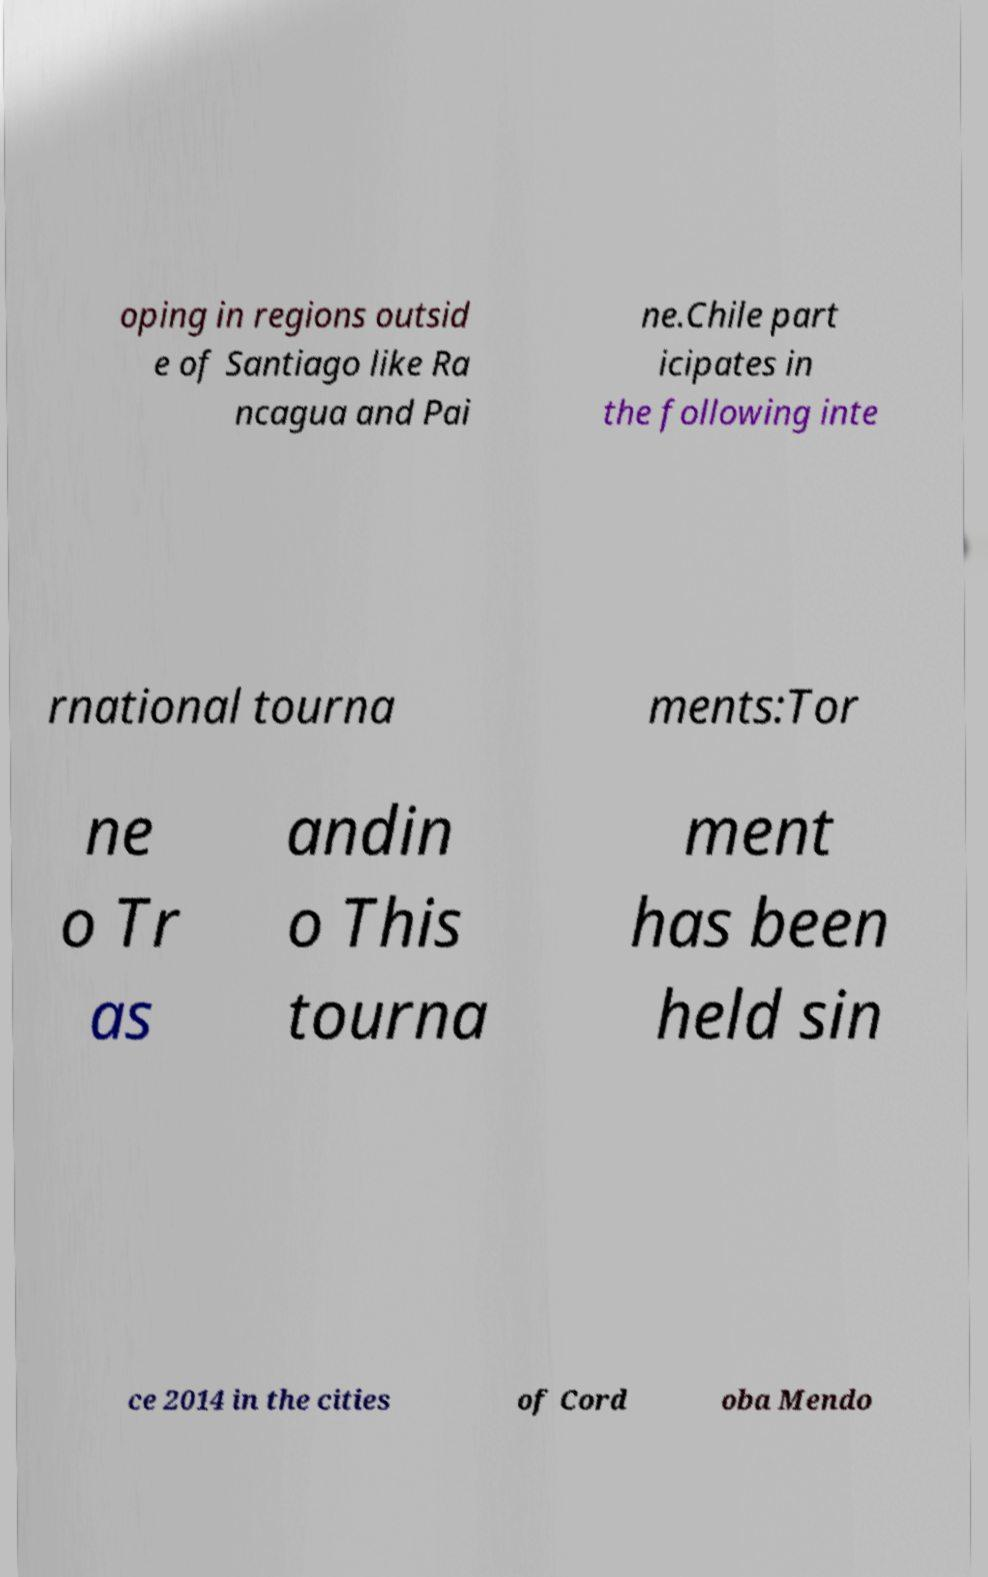Could you extract and type out the text from this image? oping in regions outsid e of Santiago like Ra ncagua and Pai ne.Chile part icipates in the following inte rnational tourna ments:Tor ne o Tr as andin o This tourna ment has been held sin ce 2014 in the cities of Cord oba Mendo 